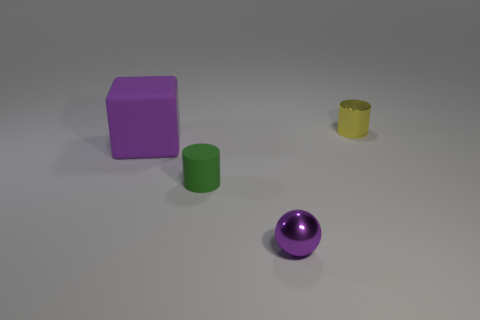Can you describe the lighting and shadows in the scene? Certainly. The image has a soft and diffuse lighting which suggests an indoor setting with likely artificial light sources. The shadows cast by the objects are soft-edged and relatively short, falling mainly to the right of the objects, indicating that the light source is to the left side of the scene. The lighting and shadows together create a gentle sense of depth and dimensionality in the composition. 